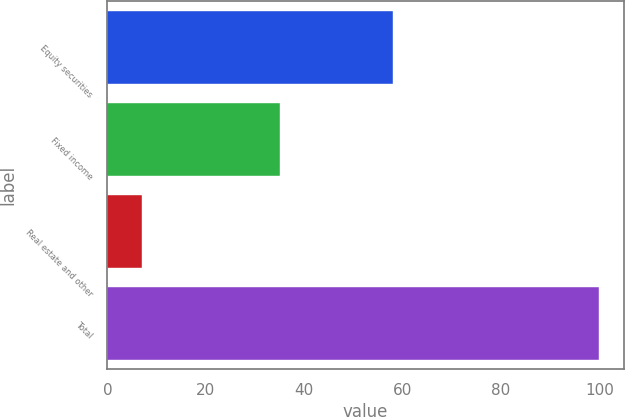Convert chart. <chart><loc_0><loc_0><loc_500><loc_500><bar_chart><fcel>Equity securities<fcel>Fixed income<fcel>Real estate and other<fcel>Total<nl><fcel>58<fcel>35<fcel>7<fcel>100<nl></chart> 